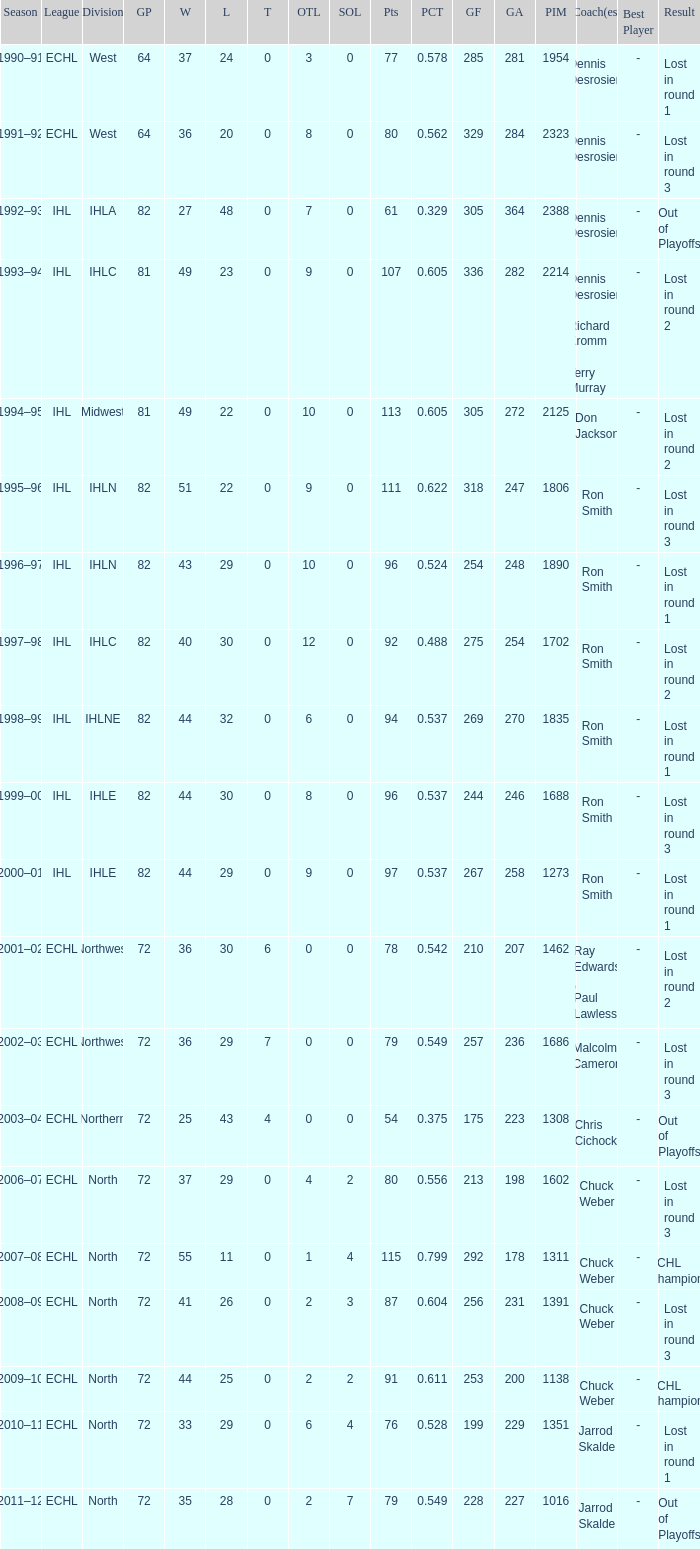What was the minimum L if the GA is 272? 22.0. 